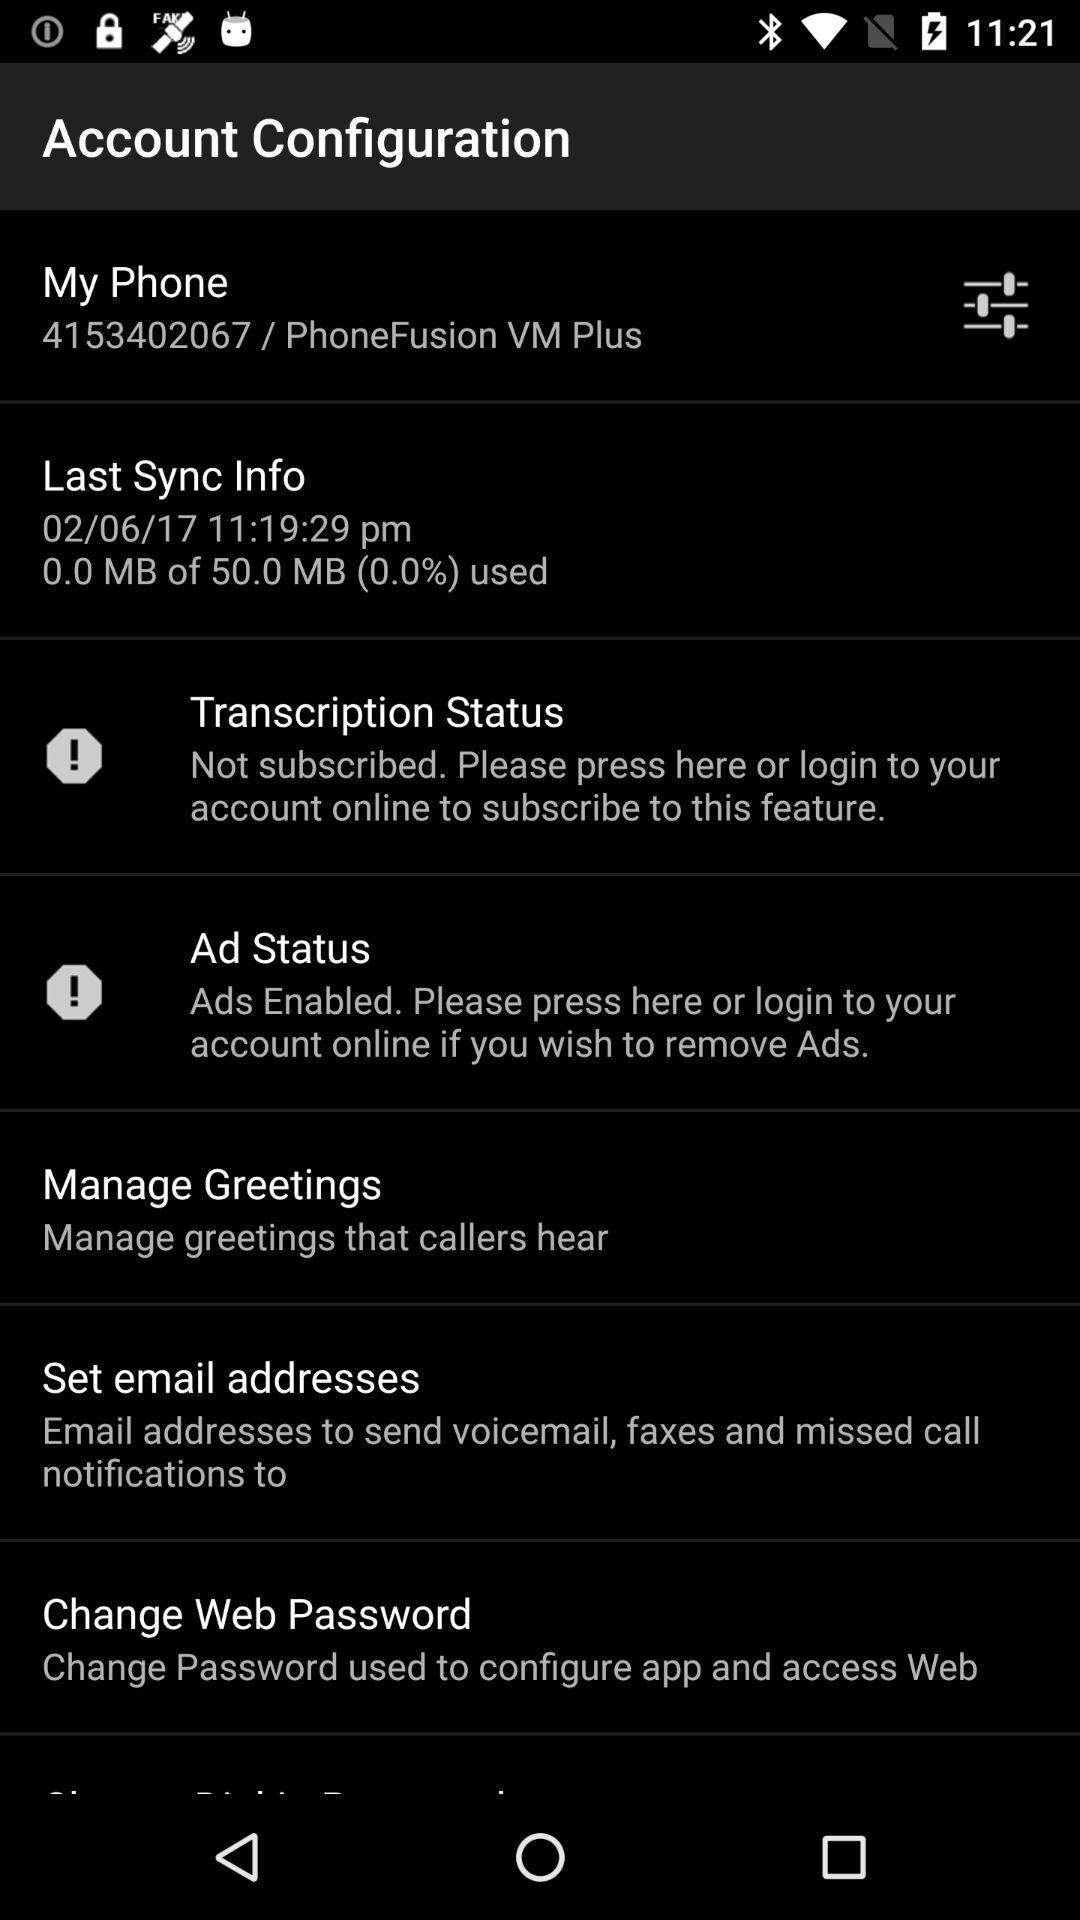What is the given phone number? The given phone number is 4153402067. 